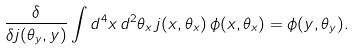Convert formula to latex. <formula><loc_0><loc_0><loc_500><loc_500>\frac { \delta } { \delta j ( \theta _ { y } , y ) } \int d ^ { 4 } x \, d ^ { 2 } \theta _ { x } \, j ( x , \theta _ { x } ) \, \phi ( x , \theta _ { x } ) = \phi ( y , \theta _ { y } ) .</formula> 